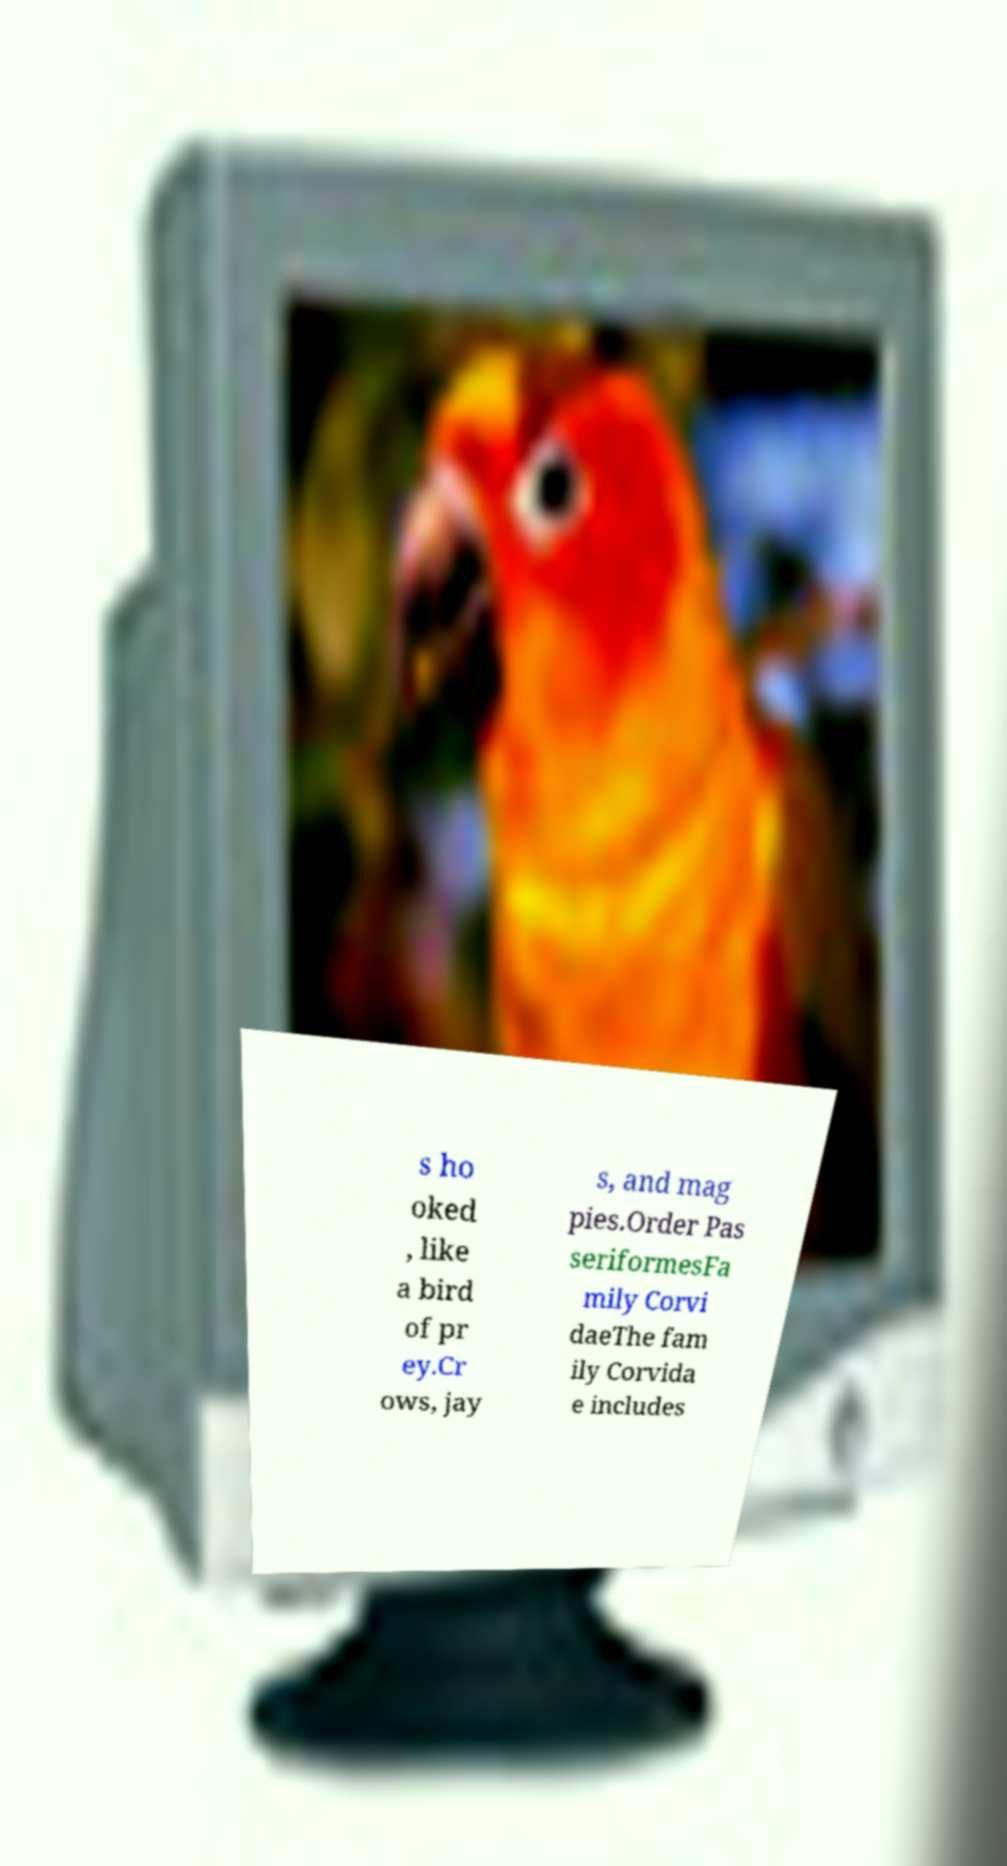Could you extract and type out the text from this image? s ho oked , like a bird of pr ey.Cr ows, jay s, and mag pies.Order Pas seriformesFa mily Corvi daeThe fam ily Corvida e includes 